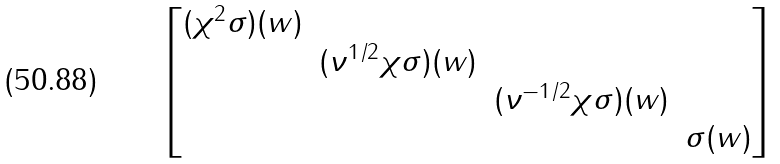<formula> <loc_0><loc_0><loc_500><loc_500>\begin{bmatrix} ( \chi ^ { 2 } \sigma ) ( w ) \\ & ( \nu ^ { 1 / 2 } \chi \sigma ) ( w ) \\ & & ( \nu ^ { - 1 / 2 } \chi \sigma ) ( w ) \\ & & & \sigma ( w ) \end{bmatrix}</formula> 